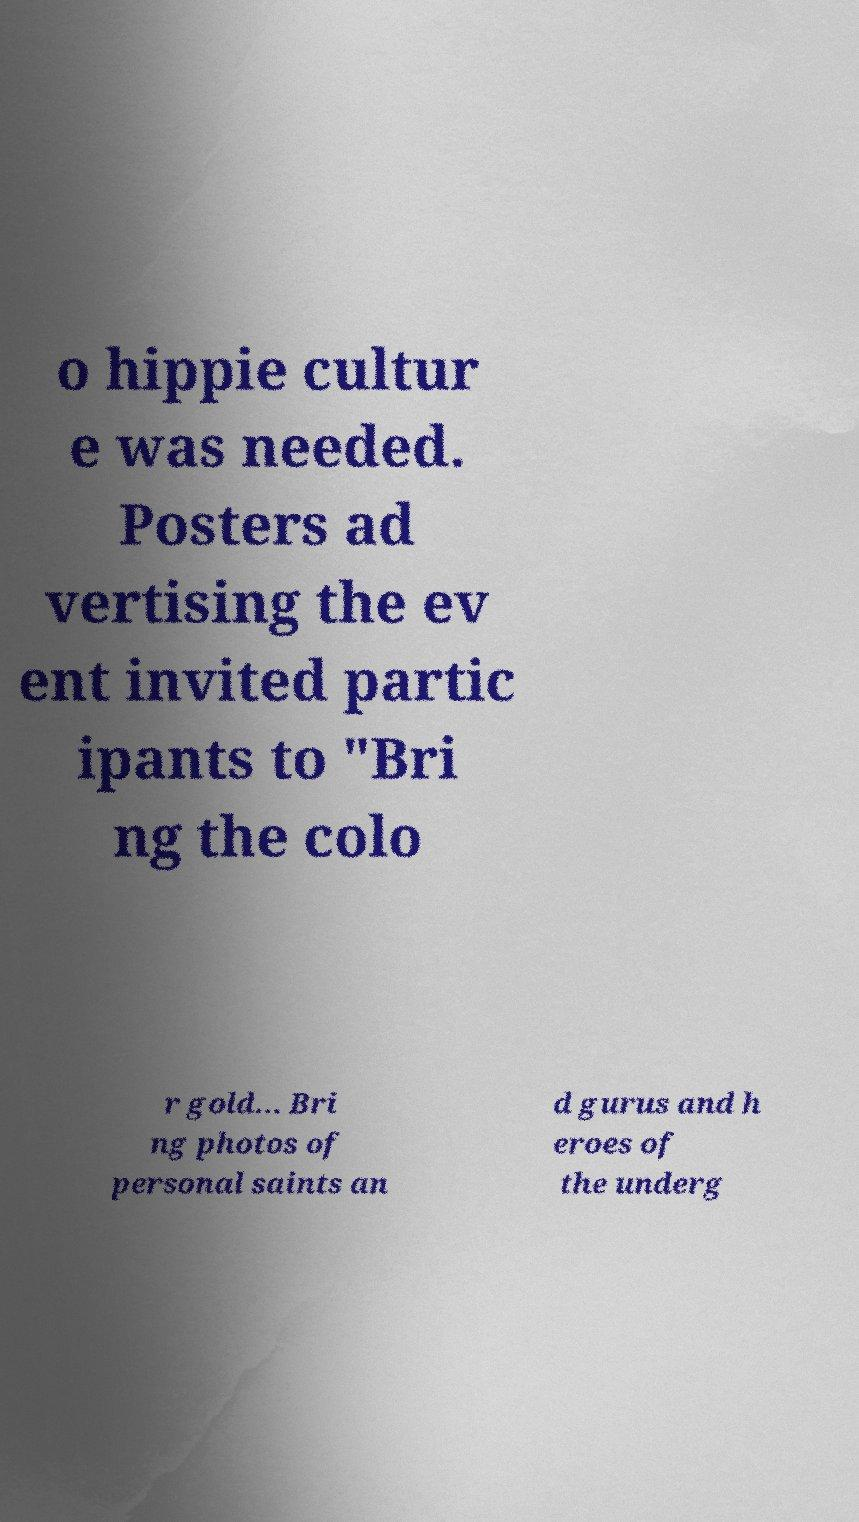Please read and relay the text visible in this image. What does it say? o hippie cultur e was needed. Posters ad vertising the ev ent invited partic ipants to "Bri ng the colo r gold... Bri ng photos of personal saints an d gurus and h eroes of the underg 